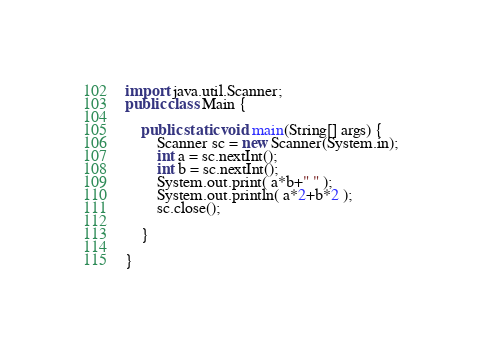<code> <loc_0><loc_0><loc_500><loc_500><_Java_>import java.util.Scanner; 
public class Main {

	public static void main(String[] args) {
		Scanner sc = new Scanner(System.in);
		int a = sc.nextInt();
        int b = sc.nextInt();
		System.out.print( a*b+" " );
        System.out.println( a*2+b*2 );
		sc.close();

	}

}

</code> 